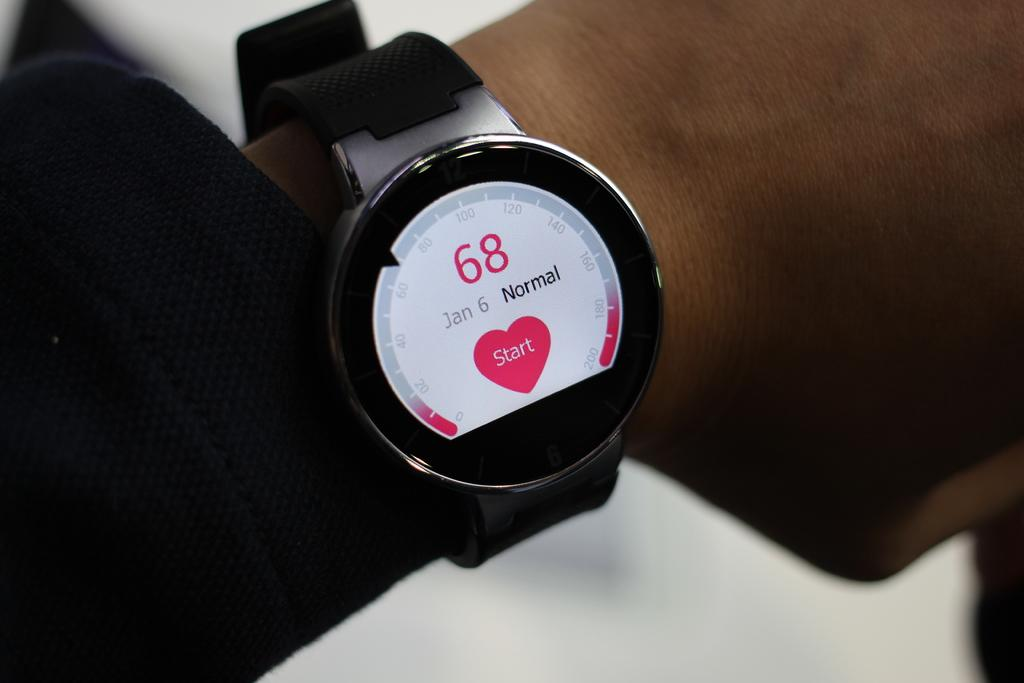<image>
Write a terse but informative summary of the picture. A watch has a white face and the number 68 on it. 